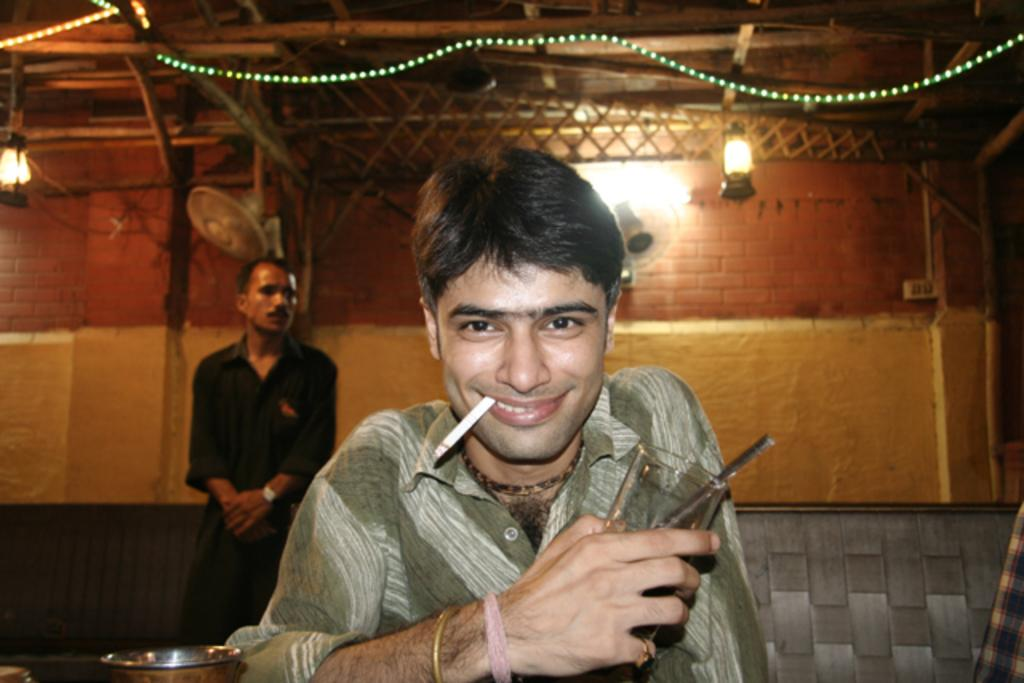What is the man in the image doing? The man is sitting in the image and holding a glass. What activity is the man engaged in? The man is smoking in the image. Can you describe the background of the image? There is a man standing in the background of the image, and there is a wall visible as well. What objects can be seen in the image that might provide light or air circulation? There are fans and lights visible in the image. What type of pencil is the man using to balance on his nose in the image? There is no pencil or balancing act present in the image; the man is simply sitting and smoking. What color is the sweater the man is wearing in the image? The man's clothing is not described in the image, so we cannot determine the color of any sweater he might be wearing. 